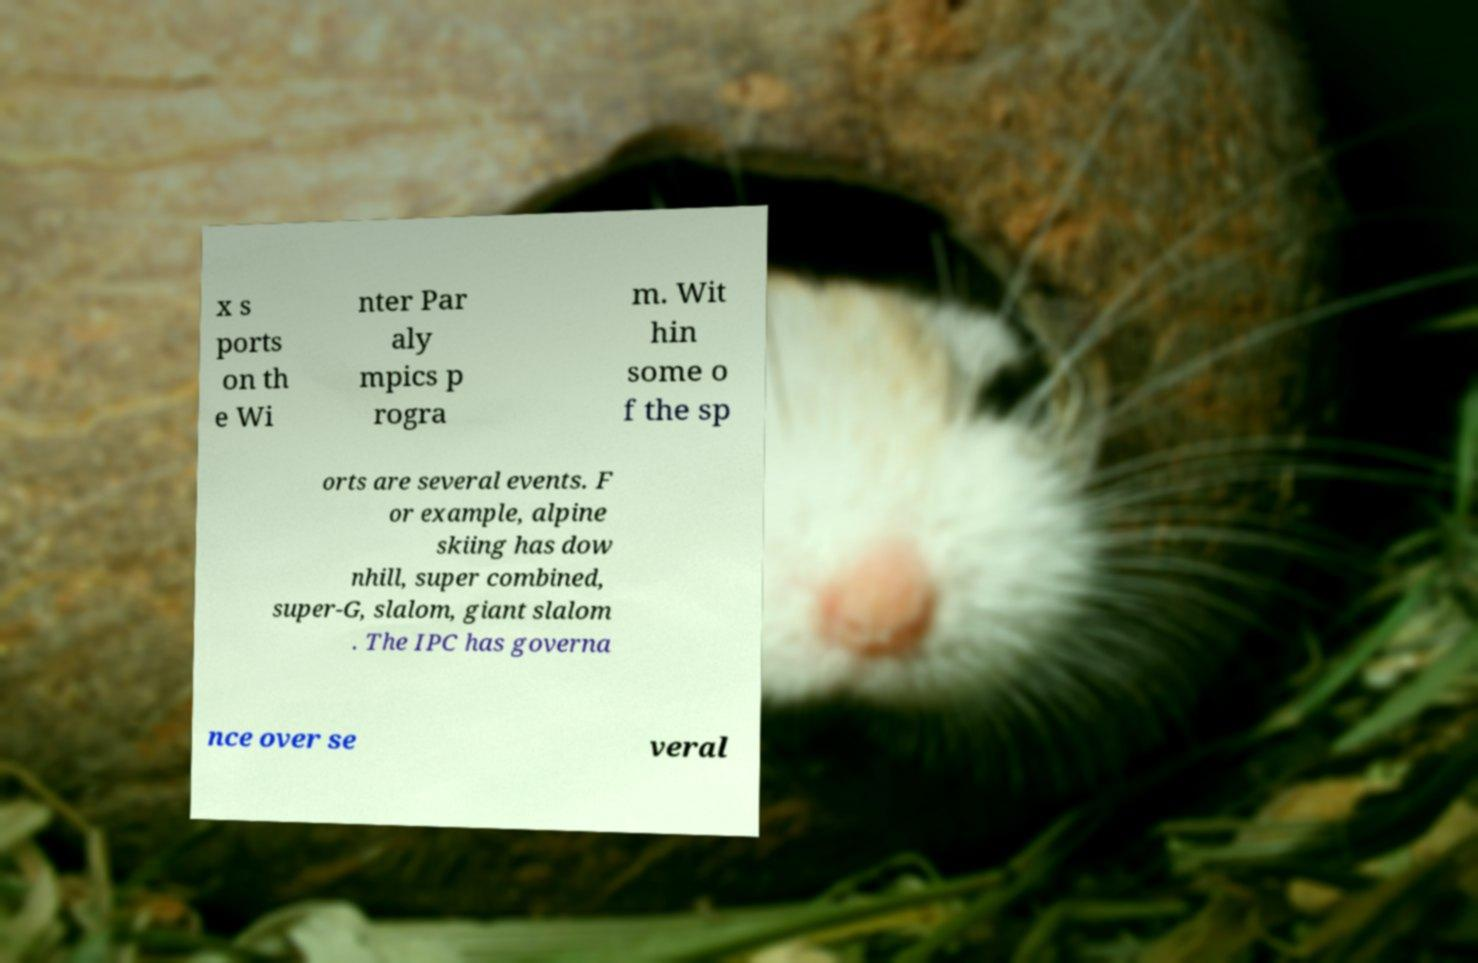Can you accurately transcribe the text from the provided image for me? x s ports on th e Wi nter Par aly mpics p rogra m. Wit hin some o f the sp orts are several events. F or example, alpine skiing has dow nhill, super combined, super-G, slalom, giant slalom . The IPC has governa nce over se veral 